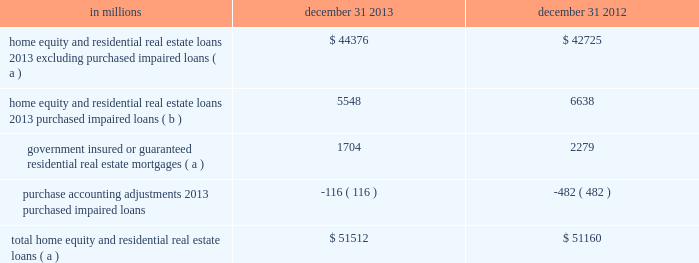Is used to monitor the risk in the loan classes .
Loans with higher fico scores and lower ltvs tend to have a lower level of risk .
Conversely , loans with lower fico scores , higher ltvs , and in certain geographic locations tend to have a higher level of risk .
In the first quarter of 2013 , we refined our process for the home equity and residential real estate asset quality indicators shown in the tables .
These refinements include , but are not limited to , improvements in the process for determining lien position and ltv in both table 67 and table 68 .
Additionally , as of the first quarter of 2013 , we are now presenting table 67 at recorded investment as opposed to our prior presentation of outstanding balance .
Table 68 continues to be presented at outstanding balance .
Both the 2013 and 2012 period end balance disclosures are presented in the below tables using this refined process .
Consumer purchased impaired loan class estimates of the expected cash flows primarily determine the credit impacts of consumer purchased impaired loans .
Consumer cash flow estimates are influenced by a number of credit related items , which include , but are not limited to : estimated real estate values , payment patterns , updated fico scores , the current economic environment , updated ltv ratios and the date of origination .
These key factors are monitored to help ensure that concentrations of risk are mitigated and cash flows are maximized .
See note 6 purchased loans for additional information .
Table 66 : home equity and residential real estate balances in millions december 31 december 31 home equity and residential real estate loans 2013 excluding purchased impaired loans ( a ) $ 44376 $ 42725 home equity and residential real estate loans 2013 purchased impaired loans ( b ) 5548 6638 government insured or guaranteed residential real estate mortgages ( a ) 1704 2279 purchase accounting adjustments 2013 purchased impaired loans ( 116 ) ( 482 ) total home equity and residential real estate loans ( a ) $ 51512 $ 51160 ( a ) represents recorded investment .
( b ) represents outstanding balance .
136 the pnc financial services group , inc .
2013 form 10-k .
Is used to monitor the risk in the loan classes .
Loans with higher fico scores and lower ltvs tend to have a lower level of risk .
Conversely , loans with lower fico scores , higher ltvs , and in certain geographic locations tend to have a higher level of risk .
In the first quarter of 2013 , we refined our process for the home equity and residential real estate asset quality indicators shown in the following tables .
These refinements include , but are not limited to , improvements in the process for determining lien position and ltv in both table 67 and table 68 .
Additionally , as of the first quarter of 2013 , we are now presenting table 67 at recorded investment as opposed to our prior presentation of outstanding balance .
Table 68 continues to be presented at outstanding balance .
Both the 2013 and 2012 period end balance disclosures are presented in the below tables using this refined process .
Consumer purchased impaired loan class estimates of the expected cash flows primarily determine the credit impacts of consumer purchased impaired loans .
Consumer cash flow estimates are influenced by a number of credit related items , which include , but are not limited to : estimated real estate values , payment patterns , updated fico scores , the current economic environment , updated ltv ratios and the date of origination .
These key factors are monitored to help ensure that concentrations of risk are mitigated and cash flows are maximized .
See note 6 purchased loans for additional information .
Table 66 : home equity and residential real estate balances in millions december 31 december 31 home equity and residential real estate loans 2013 excluding purchased impaired loans ( a ) $ 44376 $ 42725 home equity and residential real estate loans 2013 purchased impaired loans ( b ) 5548 6638 government insured or guaranteed residential real estate mortgages ( a ) 1704 2279 purchase accounting adjustments 2013 purchased impaired loans ( 116 ) ( 482 ) total home equity and residential real estate loans ( a ) $ 51512 $ 51160 ( a ) represents recorded investment .
( b ) represents outstanding balance .
136 the pnc financial services group , inc .
2013 form 10-k .
Was december 31 2013 home equity and residential real estate loans 2013 excluding purchased impaired loans greater than purchased impaired loans? 
Computations: (44376 > 5548)
Answer: yes. 